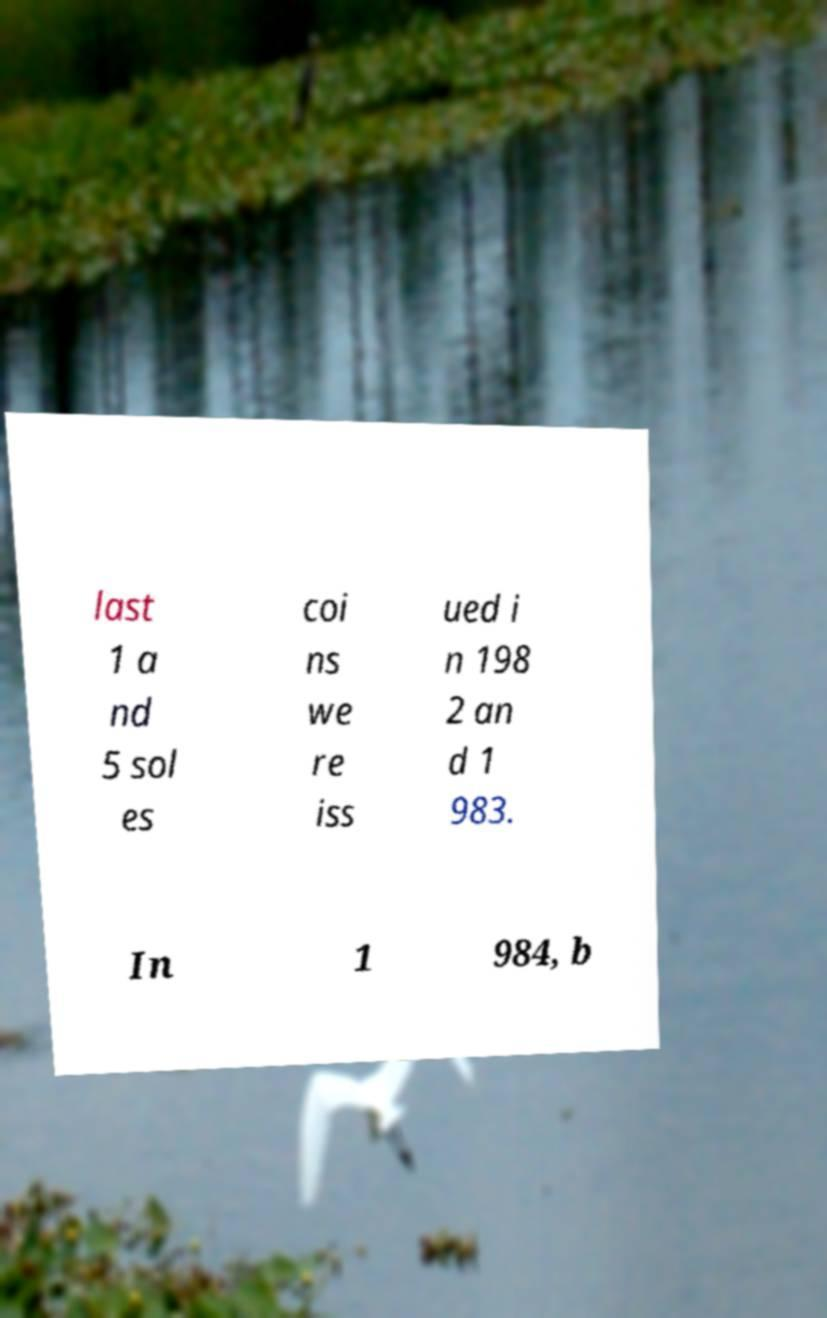Can you accurately transcribe the text from the provided image for me? last 1 a nd 5 sol es coi ns we re iss ued i n 198 2 an d 1 983. In 1 984, b 